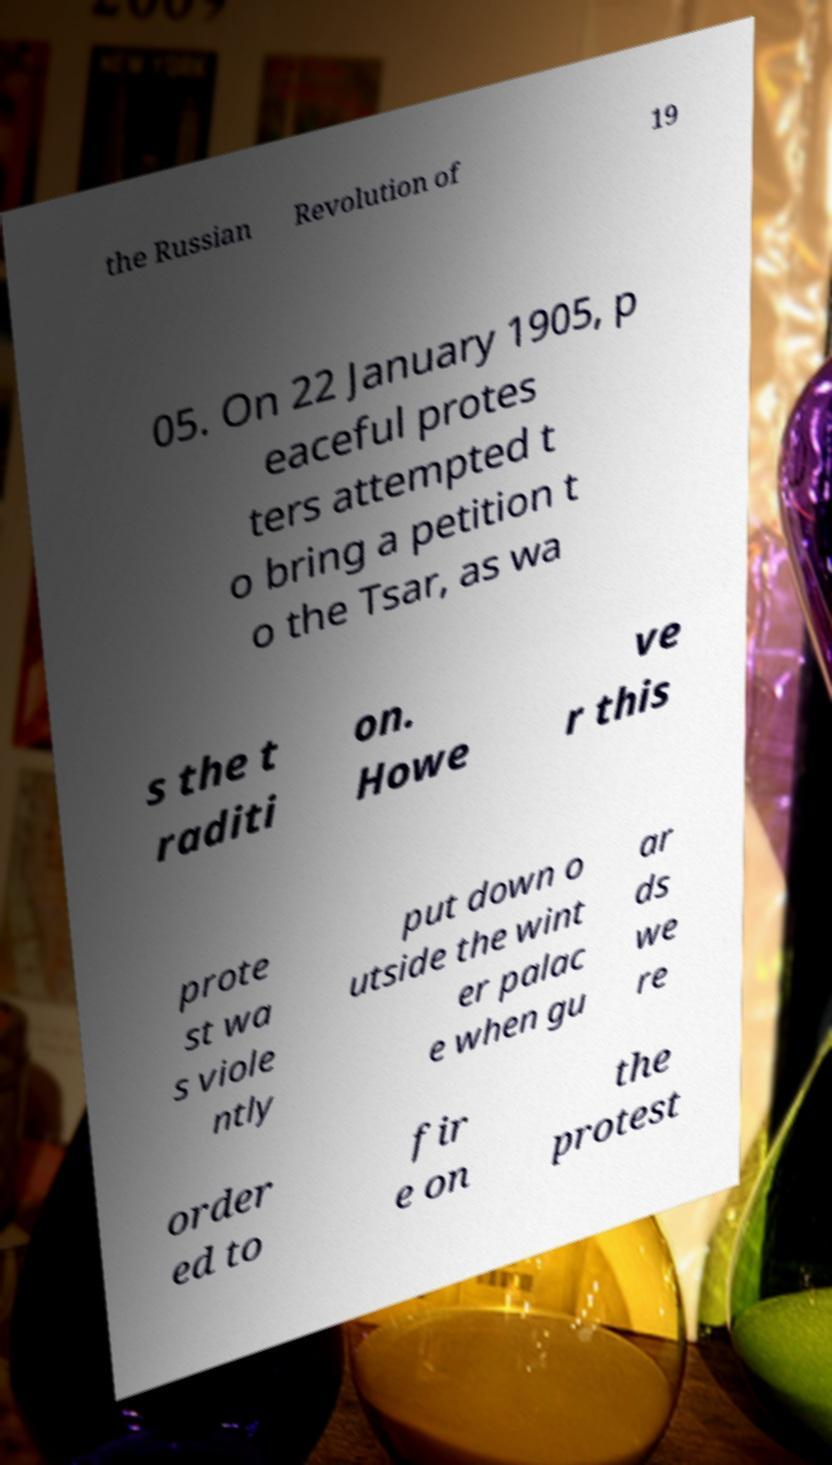There's text embedded in this image that I need extracted. Can you transcribe it verbatim? the Russian Revolution of 19 05. On 22 January 1905, p eaceful protes ters attempted t o bring a petition t o the Tsar, as wa s the t raditi on. Howe ve r this prote st wa s viole ntly put down o utside the wint er palac e when gu ar ds we re order ed to fir e on the protest 